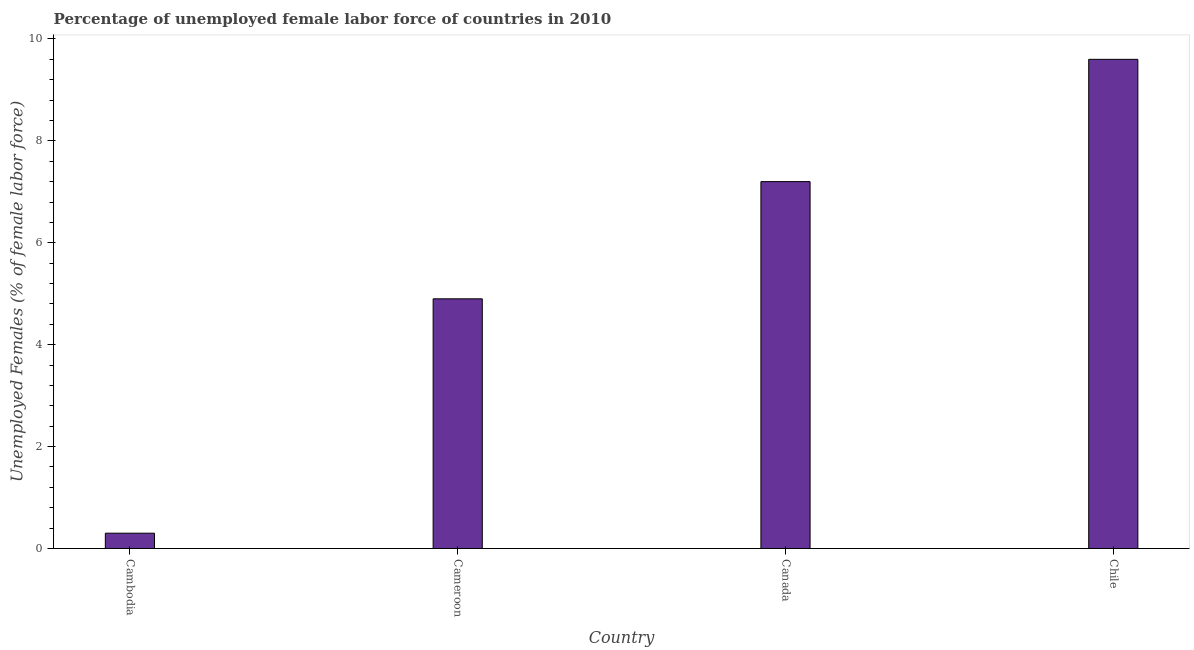Does the graph contain any zero values?
Make the answer very short. No. Does the graph contain grids?
Provide a short and direct response. No. What is the title of the graph?
Ensure brevity in your answer.  Percentage of unemployed female labor force of countries in 2010. What is the label or title of the X-axis?
Provide a succinct answer. Country. What is the label or title of the Y-axis?
Offer a very short reply. Unemployed Females (% of female labor force). What is the total unemployed female labour force in Cambodia?
Make the answer very short. 0.3. Across all countries, what is the maximum total unemployed female labour force?
Ensure brevity in your answer.  9.6. Across all countries, what is the minimum total unemployed female labour force?
Offer a very short reply. 0.3. In which country was the total unemployed female labour force maximum?
Offer a terse response. Chile. In which country was the total unemployed female labour force minimum?
Offer a very short reply. Cambodia. What is the sum of the total unemployed female labour force?
Provide a succinct answer. 22. What is the difference between the total unemployed female labour force in Canada and Chile?
Your response must be concise. -2.4. What is the average total unemployed female labour force per country?
Make the answer very short. 5.5. What is the median total unemployed female labour force?
Offer a terse response. 6.05. What is the ratio of the total unemployed female labour force in Cambodia to that in Canada?
Ensure brevity in your answer.  0.04. Is the difference between the total unemployed female labour force in Cameroon and Chile greater than the difference between any two countries?
Provide a short and direct response. No. What is the difference between the highest and the second highest total unemployed female labour force?
Offer a terse response. 2.4. Is the sum of the total unemployed female labour force in Canada and Chile greater than the maximum total unemployed female labour force across all countries?
Ensure brevity in your answer.  Yes. What is the difference between the highest and the lowest total unemployed female labour force?
Your answer should be very brief. 9.3. In how many countries, is the total unemployed female labour force greater than the average total unemployed female labour force taken over all countries?
Give a very brief answer. 2. How many bars are there?
Provide a short and direct response. 4. Are all the bars in the graph horizontal?
Keep it short and to the point. No. What is the difference between two consecutive major ticks on the Y-axis?
Offer a very short reply. 2. What is the Unemployed Females (% of female labor force) in Cambodia?
Ensure brevity in your answer.  0.3. What is the Unemployed Females (% of female labor force) of Cameroon?
Offer a very short reply. 4.9. What is the Unemployed Females (% of female labor force) of Canada?
Your answer should be very brief. 7.2. What is the Unemployed Females (% of female labor force) of Chile?
Offer a very short reply. 9.6. What is the difference between the Unemployed Females (% of female labor force) in Cambodia and Canada?
Keep it short and to the point. -6.9. What is the difference between the Unemployed Females (% of female labor force) in Cameroon and Canada?
Ensure brevity in your answer.  -2.3. What is the ratio of the Unemployed Females (% of female labor force) in Cambodia to that in Cameroon?
Your answer should be compact. 0.06. What is the ratio of the Unemployed Females (% of female labor force) in Cambodia to that in Canada?
Your answer should be very brief. 0.04. What is the ratio of the Unemployed Females (% of female labor force) in Cambodia to that in Chile?
Offer a very short reply. 0.03. What is the ratio of the Unemployed Females (% of female labor force) in Cameroon to that in Canada?
Your answer should be compact. 0.68. What is the ratio of the Unemployed Females (% of female labor force) in Cameroon to that in Chile?
Provide a succinct answer. 0.51. What is the ratio of the Unemployed Females (% of female labor force) in Canada to that in Chile?
Make the answer very short. 0.75. 